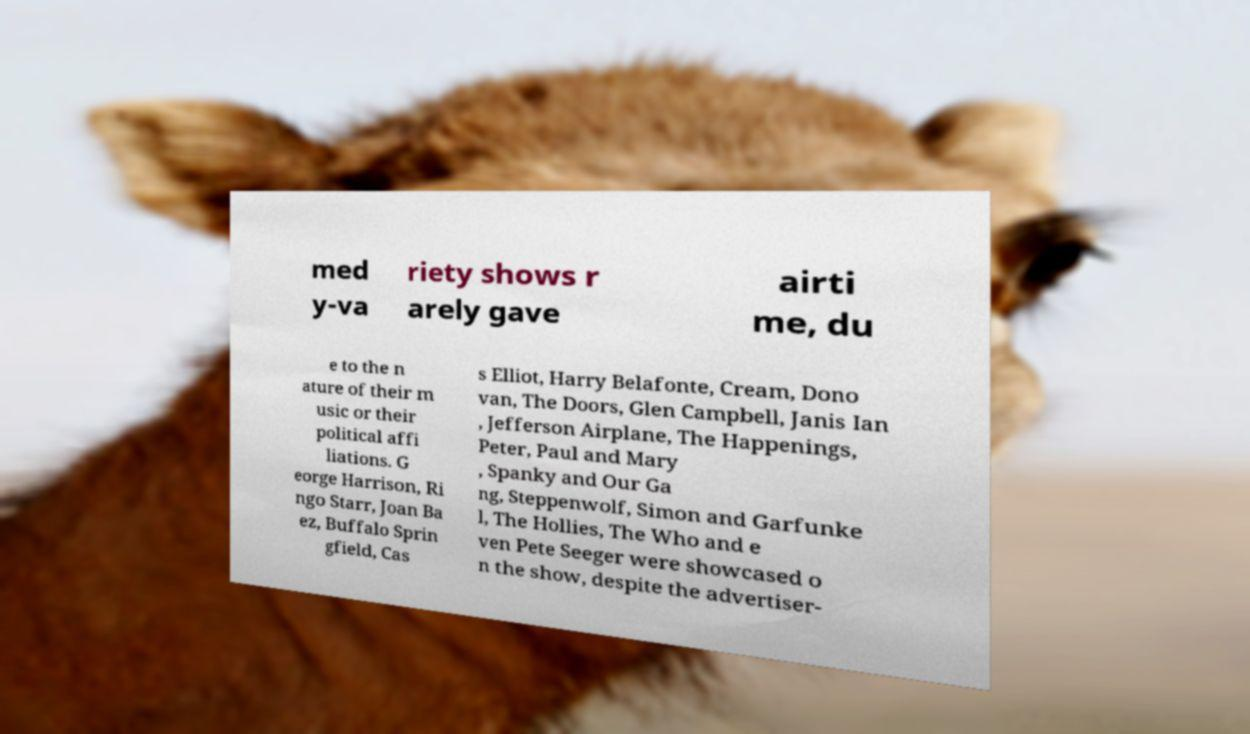I need the written content from this picture converted into text. Can you do that? med y-va riety shows r arely gave airti me, du e to the n ature of their m usic or their political affi liations. G eorge Harrison, Ri ngo Starr, Joan Ba ez, Buffalo Sprin gfield, Cas s Elliot, Harry Belafonte, Cream, Dono van, The Doors, Glen Campbell, Janis Ian , Jefferson Airplane, The Happenings, Peter, Paul and Mary , Spanky and Our Ga ng, Steppenwolf, Simon and Garfunke l, The Hollies, The Who and e ven Pete Seeger were showcased o n the show, despite the advertiser- 